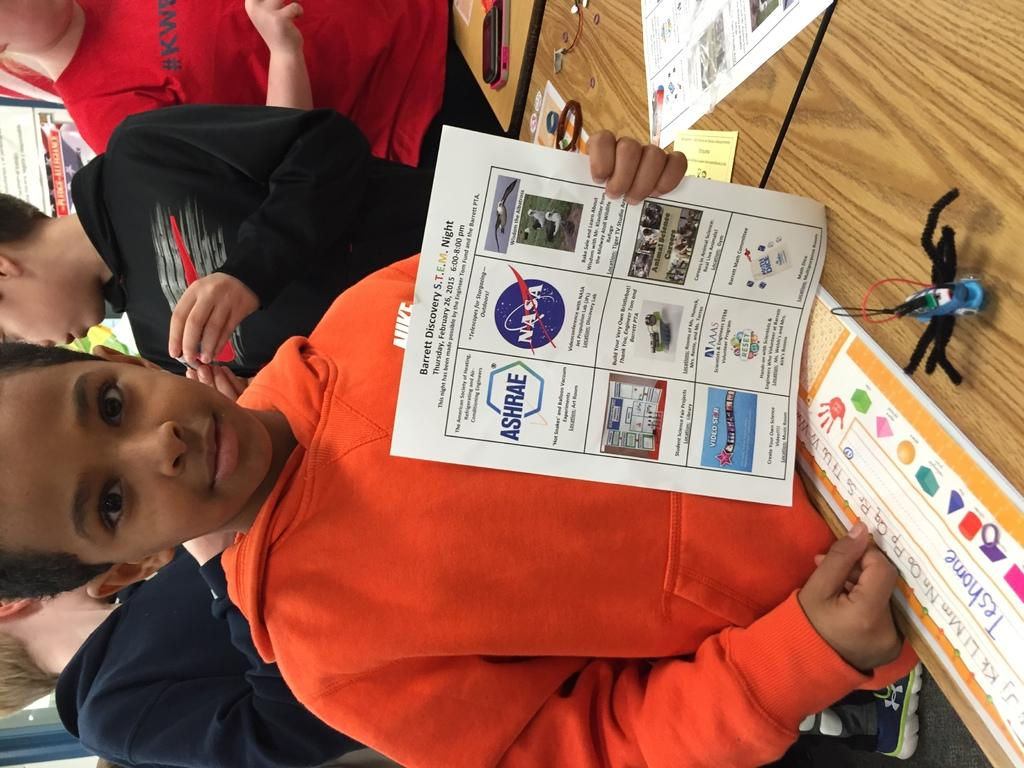Who or what can be seen in the image? There are people in the image. What else is present in the image besides the people? There are posters with text and a wooden object in the image. What part of the wooden object is responsible for creating a zephyr in the image? There is no wooden object that creates a zephyr in the image, as a zephyr is a gentle breeze and not a characteristic of a wooden object. 